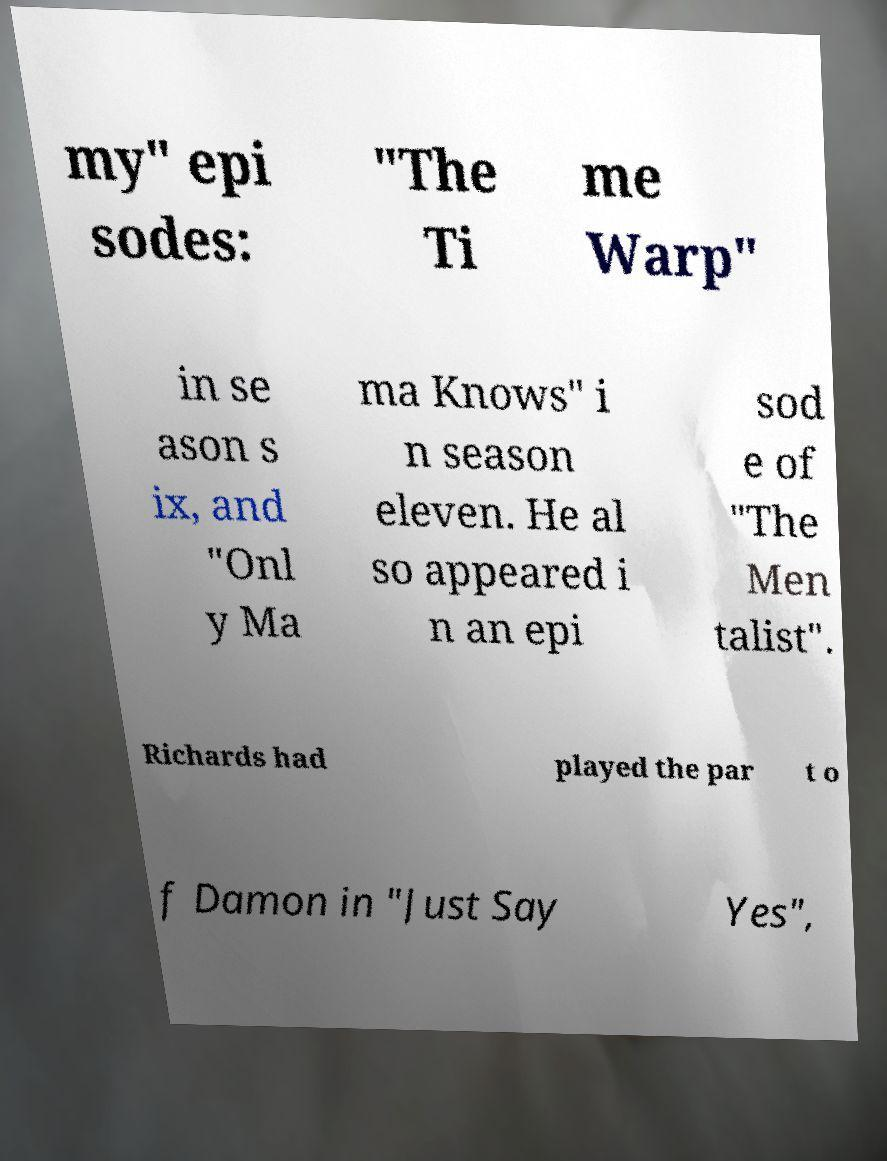For documentation purposes, I need the text within this image transcribed. Could you provide that? my" epi sodes: "The Ti me Warp" in se ason s ix, and "Onl y Ma ma Knows" i n season eleven. He al so appeared i n an epi sod e of "The Men talist". Richards had played the par t o f Damon in "Just Say Yes", 